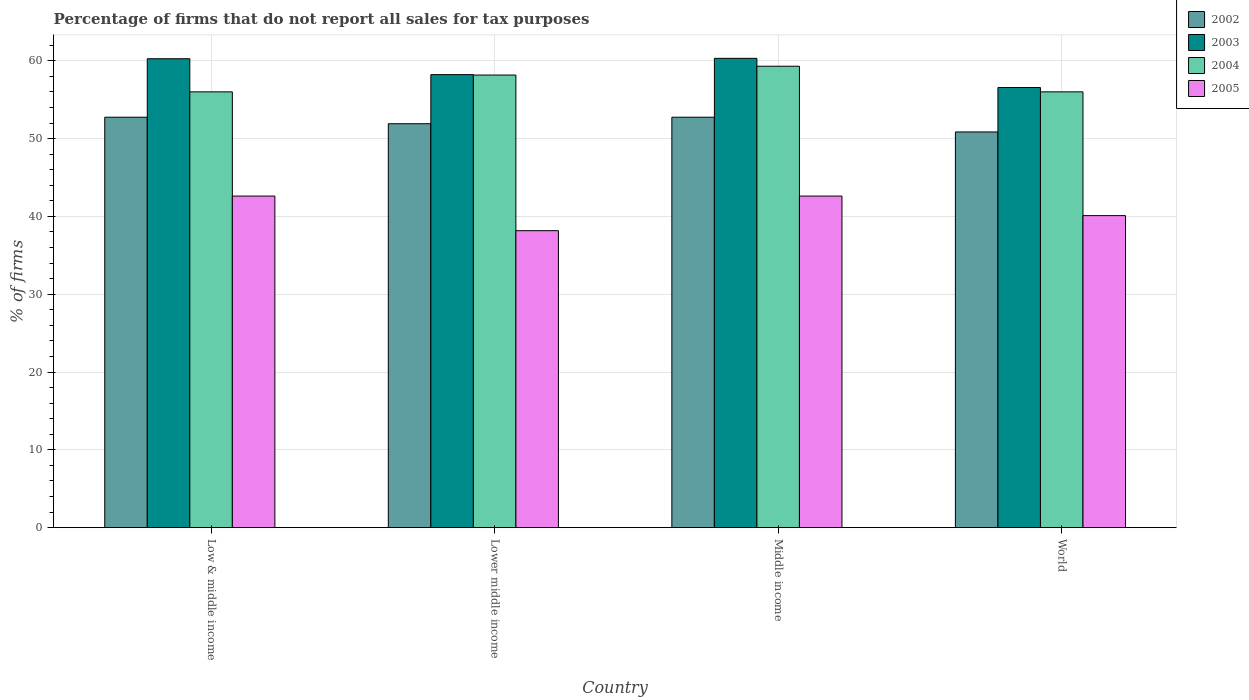How many groups of bars are there?
Your answer should be very brief. 4. What is the label of the 2nd group of bars from the left?
Ensure brevity in your answer.  Lower middle income. In how many cases, is the number of bars for a given country not equal to the number of legend labels?
Ensure brevity in your answer.  0. What is the percentage of firms that do not report all sales for tax purposes in 2003 in Lower middle income?
Give a very brief answer. 58.22. Across all countries, what is the maximum percentage of firms that do not report all sales for tax purposes in 2004?
Provide a short and direct response. 59.3. Across all countries, what is the minimum percentage of firms that do not report all sales for tax purposes in 2003?
Keep it short and to the point. 56.56. In which country was the percentage of firms that do not report all sales for tax purposes in 2002 minimum?
Ensure brevity in your answer.  World. What is the total percentage of firms that do not report all sales for tax purposes in 2002 in the graph?
Ensure brevity in your answer.  208.25. What is the difference between the percentage of firms that do not report all sales for tax purposes in 2005 in Lower middle income and that in World?
Offer a terse response. -1.94. What is the difference between the percentage of firms that do not report all sales for tax purposes in 2005 in Lower middle income and the percentage of firms that do not report all sales for tax purposes in 2003 in Middle income?
Your response must be concise. -22.15. What is the average percentage of firms that do not report all sales for tax purposes in 2003 per country?
Your answer should be very brief. 58.84. What is the difference between the percentage of firms that do not report all sales for tax purposes of/in 2005 and percentage of firms that do not report all sales for tax purposes of/in 2004 in Low & middle income?
Keep it short and to the point. -13.39. What is the ratio of the percentage of firms that do not report all sales for tax purposes in 2002 in Lower middle income to that in World?
Ensure brevity in your answer.  1.02. What is the difference between the highest and the second highest percentage of firms that do not report all sales for tax purposes in 2003?
Offer a very short reply. -2.09. What is the difference between the highest and the lowest percentage of firms that do not report all sales for tax purposes in 2002?
Your response must be concise. 1.89. Is the sum of the percentage of firms that do not report all sales for tax purposes in 2005 in Low & middle income and Middle income greater than the maximum percentage of firms that do not report all sales for tax purposes in 2003 across all countries?
Your answer should be compact. Yes. Is it the case that in every country, the sum of the percentage of firms that do not report all sales for tax purposes in 2003 and percentage of firms that do not report all sales for tax purposes in 2002 is greater than the sum of percentage of firms that do not report all sales for tax purposes in 2005 and percentage of firms that do not report all sales for tax purposes in 2004?
Your answer should be compact. No. What does the 2nd bar from the left in Low & middle income represents?
Ensure brevity in your answer.  2003. How many bars are there?
Provide a succinct answer. 16. Are all the bars in the graph horizontal?
Make the answer very short. No. How many countries are there in the graph?
Provide a short and direct response. 4. What is the difference between two consecutive major ticks on the Y-axis?
Your response must be concise. 10. Are the values on the major ticks of Y-axis written in scientific E-notation?
Give a very brief answer. No. How many legend labels are there?
Your answer should be very brief. 4. What is the title of the graph?
Offer a very short reply. Percentage of firms that do not report all sales for tax purposes. Does "1986" appear as one of the legend labels in the graph?
Offer a very short reply. No. What is the label or title of the X-axis?
Make the answer very short. Country. What is the label or title of the Y-axis?
Give a very brief answer. % of firms. What is the % of firms in 2002 in Low & middle income?
Keep it short and to the point. 52.75. What is the % of firms in 2003 in Low & middle income?
Offer a terse response. 60.26. What is the % of firms of 2004 in Low & middle income?
Provide a short and direct response. 56.01. What is the % of firms of 2005 in Low & middle income?
Your answer should be compact. 42.61. What is the % of firms of 2002 in Lower middle income?
Ensure brevity in your answer.  51.91. What is the % of firms of 2003 in Lower middle income?
Provide a succinct answer. 58.22. What is the % of firms in 2004 in Lower middle income?
Ensure brevity in your answer.  58.16. What is the % of firms of 2005 in Lower middle income?
Keep it short and to the point. 38.16. What is the % of firms in 2002 in Middle income?
Provide a short and direct response. 52.75. What is the % of firms in 2003 in Middle income?
Make the answer very short. 60.31. What is the % of firms of 2004 in Middle income?
Offer a very short reply. 59.3. What is the % of firms of 2005 in Middle income?
Offer a terse response. 42.61. What is the % of firms of 2002 in World?
Ensure brevity in your answer.  50.85. What is the % of firms in 2003 in World?
Make the answer very short. 56.56. What is the % of firms in 2004 in World?
Offer a very short reply. 56.01. What is the % of firms of 2005 in World?
Your answer should be compact. 40.1. Across all countries, what is the maximum % of firms of 2002?
Offer a very short reply. 52.75. Across all countries, what is the maximum % of firms of 2003?
Your answer should be very brief. 60.31. Across all countries, what is the maximum % of firms in 2004?
Your answer should be compact. 59.3. Across all countries, what is the maximum % of firms in 2005?
Offer a terse response. 42.61. Across all countries, what is the minimum % of firms in 2002?
Your answer should be compact. 50.85. Across all countries, what is the minimum % of firms of 2003?
Keep it short and to the point. 56.56. Across all countries, what is the minimum % of firms in 2004?
Your answer should be compact. 56.01. Across all countries, what is the minimum % of firms of 2005?
Your answer should be compact. 38.16. What is the total % of firms in 2002 in the graph?
Give a very brief answer. 208.25. What is the total % of firms of 2003 in the graph?
Provide a short and direct response. 235.35. What is the total % of firms in 2004 in the graph?
Provide a short and direct response. 229.47. What is the total % of firms of 2005 in the graph?
Keep it short and to the point. 163.48. What is the difference between the % of firms in 2002 in Low & middle income and that in Lower middle income?
Your answer should be very brief. 0.84. What is the difference between the % of firms in 2003 in Low & middle income and that in Lower middle income?
Offer a terse response. 2.04. What is the difference between the % of firms in 2004 in Low & middle income and that in Lower middle income?
Offer a terse response. -2.16. What is the difference between the % of firms in 2005 in Low & middle income and that in Lower middle income?
Your answer should be compact. 4.45. What is the difference between the % of firms of 2003 in Low & middle income and that in Middle income?
Keep it short and to the point. -0.05. What is the difference between the % of firms in 2004 in Low & middle income and that in Middle income?
Provide a succinct answer. -3.29. What is the difference between the % of firms of 2005 in Low & middle income and that in Middle income?
Your answer should be compact. 0. What is the difference between the % of firms in 2002 in Low & middle income and that in World?
Provide a succinct answer. 1.89. What is the difference between the % of firms of 2005 in Low & middle income and that in World?
Offer a very short reply. 2.51. What is the difference between the % of firms in 2002 in Lower middle income and that in Middle income?
Offer a terse response. -0.84. What is the difference between the % of firms of 2003 in Lower middle income and that in Middle income?
Your response must be concise. -2.09. What is the difference between the % of firms of 2004 in Lower middle income and that in Middle income?
Offer a terse response. -1.13. What is the difference between the % of firms of 2005 in Lower middle income and that in Middle income?
Offer a terse response. -4.45. What is the difference between the % of firms of 2002 in Lower middle income and that in World?
Give a very brief answer. 1.06. What is the difference between the % of firms in 2003 in Lower middle income and that in World?
Your answer should be very brief. 1.66. What is the difference between the % of firms of 2004 in Lower middle income and that in World?
Keep it short and to the point. 2.16. What is the difference between the % of firms in 2005 in Lower middle income and that in World?
Provide a short and direct response. -1.94. What is the difference between the % of firms of 2002 in Middle income and that in World?
Give a very brief answer. 1.89. What is the difference between the % of firms in 2003 in Middle income and that in World?
Your answer should be very brief. 3.75. What is the difference between the % of firms of 2004 in Middle income and that in World?
Your answer should be compact. 3.29. What is the difference between the % of firms in 2005 in Middle income and that in World?
Your answer should be very brief. 2.51. What is the difference between the % of firms of 2002 in Low & middle income and the % of firms of 2003 in Lower middle income?
Provide a succinct answer. -5.47. What is the difference between the % of firms in 2002 in Low & middle income and the % of firms in 2004 in Lower middle income?
Your response must be concise. -5.42. What is the difference between the % of firms of 2002 in Low & middle income and the % of firms of 2005 in Lower middle income?
Give a very brief answer. 14.58. What is the difference between the % of firms of 2003 in Low & middle income and the % of firms of 2004 in Lower middle income?
Provide a short and direct response. 2.1. What is the difference between the % of firms of 2003 in Low & middle income and the % of firms of 2005 in Lower middle income?
Make the answer very short. 22.1. What is the difference between the % of firms in 2004 in Low & middle income and the % of firms in 2005 in Lower middle income?
Keep it short and to the point. 17.84. What is the difference between the % of firms in 2002 in Low & middle income and the % of firms in 2003 in Middle income?
Provide a succinct answer. -7.57. What is the difference between the % of firms of 2002 in Low & middle income and the % of firms of 2004 in Middle income?
Provide a short and direct response. -6.55. What is the difference between the % of firms in 2002 in Low & middle income and the % of firms in 2005 in Middle income?
Offer a terse response. 10.13. What is the difference between the % of firms in 2003 in Low & middle income and the % of firms in 2004 in Middle income?
Provide a short and direct response. 0.96. What is the difference between the % of firms in 2003 in Low & middle income and the % of firms in 2005 in Middle income?
Offer a very short reply. 17.65. What is the difference between the % of firms of 2004 in Low & middle income and the % of firms of 2005 in Middle income?
Provide a succinct answer. 13.39. What is the difference between the % of firms of 2002 in Low & middle income and the % of firms of 2003 in World?
Ensure brevity in your answer.  -3.81. What is the difference between the % of firms of 2002 in Low & middle income and the % of firms of 2004 in World?
Your response must be concise. -3.26. What is the difference between the % of firms in 2002 in Low & middle income and the % of firms in 2005 in World?
Provide a short and direct response. 12.65. What is the difference between the % of firms in 2003 in Low & middle income and the % of firms in 2004 in World?
Offer a terse response. 4.25. What is the difference between the % of firms in 2003 in Low & middle income and the % of firms in 2005 in World?
Provide a short and direct response. 20.16. What is the difference between the % of firms of 2004 in Low & middle income and the % of firms of 2005 in World?
Your response must be concise. 15.91. What is the difference between the % of firms in 2002 in Lower middle income and the % of firms in 2003 in Middle income?
Provide a short and direct response. -8.4. What is the difference between the % of firms of 2002 in Lower middle income and the % of firms of 2004 in Middle income?
Ensure brevity in your answer.  -7.39. What is the difference between the % of firms in 2002 in Lower middle income and the % of firms in 2005 in Middle income?
Ensure brevity in your answer.  9.3. What is the difference between the % of firms of 2003 in Lower middle income and the % of firms of 2004 in Middle income?
Ensure brevity in your answer.  -1.08. What is the difference between the % of firms of 2003 in Lower middle income and the % of firms of 2005 in Middle income?
Provide a short and direct response. 15.61. What is the difference between the % of firms in 2004 in Lower middle income and the % of firms in 2005 in Middle income?
Offer a terse response. 15.55. What is the difference between the % of firms of 2002 in Lower middle income and the % of firms of 2003 in World?
Your answer should be very brief. -4.65. What is the difference between the % of firms in 2002 in Lower middle income and the % of firms in 2004 in World?
Ensure brevity in your answer.  -4.1. What is the difference between the % of firms in 2002 in Lower middle income and the % of firms in 2005 in World?
Your response must be concise. 11.81. What is the difference between the % of firms of 2003 in Lower middle income and the % of firms of 2004 in World?
Provide a succinct answer. 2.21. What is the difference between the % of firms in 2003 in Lower middle income and the % of firms in 2005 in World?
Provide a short and direct response. 18.12. What is the difference between the % of firms of 2004 in Lower middle income and the % of firms of 2005 in World?
Give a very brief answer. 18.07. What is the difference between the % of firms in 2002 in Middle income and the % of firms in 2003 in World?
Offer a terse response. -3.81. What is the difference between the % of firms of 2002 in Middle income and the % of firms of 2004 in World?
Give a very brief answer. -3.26. What is the difference between the % of firms of 2002 in Middle income and the % of firms of 2005 in World?
Offer a terse response. 12.65. What is the difference between the % of firms of 2003 in Middle income and the % of firms of 2004 in World?
Offer a terse response. 4.31. What is the difference between the % of firms in 2003 in Middle income and the % of firms in 2005 in World?
Provide a short and direct response. 20.21. What is the difference between the % of firms of 2004 in Middle income and the % of firms of 2005 in World?
Keep it short and to the point. 19.2. What is the average % of firms of 2002 per country?
Your answer should be very brief. 52.06. What is the average % of firms of 2003 per country?
Your answer should be very brief. 58.84. What is the average % of firms of 2004 per country?
Your answer should be compact. 57.37. What is the average % of firms in 2005 per country?
Offer a very short reply. 40.87. What is the difference between the % of firms in 2002 and % of firms in 2003 in Low & middle income?
Your answer should be very brief. -7.51. What is the difference between the % of firms in 2002 and % of firms in 2004 in Low & middle income?
Ensure brevity in your answer.  -3.26. What is the difference between the % of firms of 2002 and % of firms of 2005 in Low & middle income?
Offer a terse response. 10.13. What is the difference between the % of firms in 2003 and % of firms in 2004 in Low & middle income?
Offer a terse response. 4.25. What is the difference between the % of firms of 2003 and % of firms of 2005 in Low & middle income?
Your answer should be very brief. 17.65. What is the difference between the % of firms of 2004 and % of firms of 2005 in Low & middle income?
Your answer should be compact. 13.39. What is the difference between the % of firms of 2002 and % of firms of 2003 in Lower middle income?
Your answer should be compact. -6.31. What is the difference between the % of firms of 2002 and % of firms of 2004 in Lower middle income?
Offer a very short reply. -6.26. What is the difference between the % of firms in 2002 and % of firms in 2005 in Lower middle income?
Keep it short and to the point. 13.75. What is the difference between the % of firms of 2003 and % of firms of 2004 in Lower middle income?
Give a very brief answer. 0.05. What is the difference between the % of firms in 2003 and % of firms in 2005 in Lower middle income?
Your response must be concise. 20.06. What is the difference between the % of firms of 2004 and % of firms of 2005 in Lower middle income?
Ensure brevity in your answer.  20. What is the difference between the % of firms in 2002 and % of firms in 2003 in Middle income?
Provide a short and direct response. -7.57. What is the difference between the % of firms in 2002 and % of firms in 2004 in Middle income?
Offer a very short reply. -6.55. What is the difference between the % of firms of 2002 and % of firms of 2005 in Middle income?
Give a very brief answer. 10.13. What is the difference between the % of firms in 2003 and % of firms in 2004 in Middle income?
Provide a short and direct response. 1.02. What is the difference between the % of firms of 2003 and % of firms of 2005 in Middle income?
Provide a short and direct response. 17.7. What is the difference between the % of firms in 2004 and % of firms in 2005 in Middle income?
Offer a terse response. 16.69. What is the difference between the % of firms in 2002 and % of firms in 2003 in World?
Keep it short and to the point. -5.71. What is the difference between the % of firms in 2002 and % of firms in 2004 in World?
Offer a very short reply. -5.15. What is the difference between the % of firms in 2002 and % of firms in 2005 in World?
Offer a very short reply. 10.75. What is the difference between the % of firms in 2003 and % of firms in 2004 in World?
Offer a very short reply. 0.56. What is the difference between the % of firms of 2003 and % of firms of 2005 in World?
Your answer should be very brief. 16.46. What is the difference between the % of firms of 2004 and % of firms of 2005 in World?
Your answer should be compact. 15.91. What is the ratio of the % of firms in 2002 in Low & middle income to that in Lower middle income?
Ensure brevity in your answer.  1.02. What is the ratio of the % of firms in 2003 in Low & middle income to that in Lower middle income?
Provide a short and direct response. 1.04. What is the ratio of the % of firms in 2004 in Low & middle income to that in Lower middle income?
Provide a short and direct response. 0.96. What is the ratio of the % of firms in 2005 in Low & middle income to that in Lower middle income?
Offer a terse response. 1.12. What is the ratio of the % of firms of 2002 in Low & middle income to that in Middle income?
Offer a very short reply. 1. What is the ratio of the % of firms of 2003 in Low & middle income to that in Middle income?
Your answer should be very brief. 1. What is the ratio of the % of firms of 2004 in Low & middle income to that in Middle income?
Your answer should be very brief. 0.94. What is the ratio of the % of firms in 2005 in Low & middle income to that in Middle income?
Offer a very short reply. 1. What is the ratio of the % of firms in 2002 in Low & middle income to that in World?
Your response must be concise. 1.04. What is the ratio of the % of firms of 2003 in Low & middle income to that in World?
Your answer should be compact. 1.07. What is the ratio of the % of firms in 2005 in Low & middle income to that in World?
Make the answer very short. 1.06. What is the ratio of the % of firms of 2002 in Lower middle income to that in Middle income?
Offer a very short reply. 0.98. What is the ratio of the % of firms of 2003 in Lower middle income to that in Middle income?
Give a very brief answer. 0.97. What is the ratio of the % of firms in 2004 in Lower middle income to that in Middle income?
Your answer should be compact. 0.98. What is the ratio of the % of firms in 2005 in Lower middle income to that in Middle income?
Give a very brief answer. 0.9. What is the ratio of the % of firms of 2002 in Lower middle income to that in World?
Your response must be concise. 1.02. What is the ratio of the % of firms of 2003 in Lower middle income to that in World?
Provide a succinct answer. 1.03. What is the ratio of the % of firms in 2004 in Lower middle income to that in World?
Keep it short and to the point. 1.04. What is the ratio of the % of firms in 2005 in Lower middle income to that in World?
Offer a very short reply. 0.95. What is the ratio of the % of firms in 2002 in Middle income to that in World?
Ensure brevity in your answer.  1.04. What is the ratio of the % of firms of 2003 in Middle income to that in World?
Your response must be concise. 1.07. What is the ratio of the % of firms of 2004 in Middle income to that in World?
Make the answer very short. 1.06. What is the ratio of the % of firms of 2005 in Middle income to that in World?
Your response must be concise. 1.06. What is the difference between the highest and the second highest % of firms of 2003?
Your answer should be very brief. 0.05. What is the difference between the highest and the second highest % of firms of 2004?
Provide a short and direct response. 1.13. What is the difference between the highest and the lowest % of firms in 2002?
Your answer should be compact. 1.89. What is the difference between the highest and the lowest % of firms of 2003?
Your answer should be very brief. 3.75. What is the difference between the highest and the lowest % of firms in 2004?
Your answer should be very brief. 3.29. What is the difference between the highest and the lowest % of firms of 2005?
Offer a terse response. 4.45. 